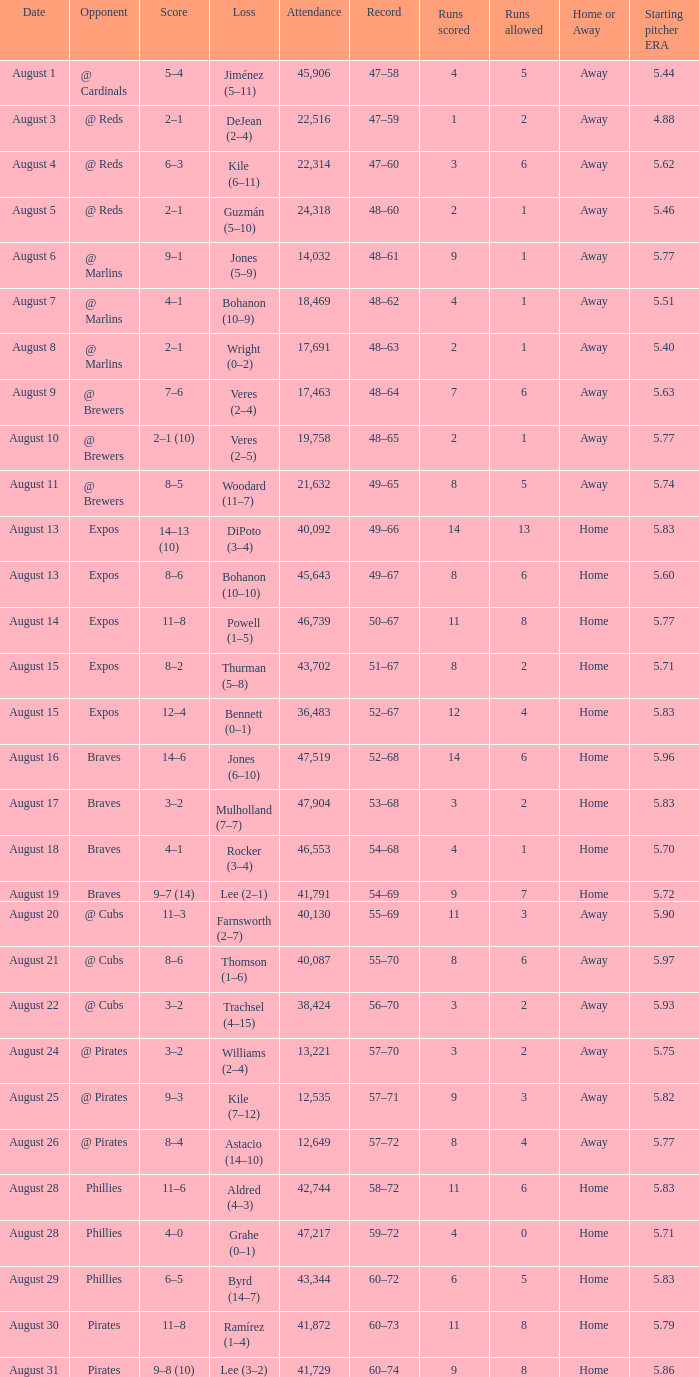What's the least amount of people present on august 26? 12649.0. 